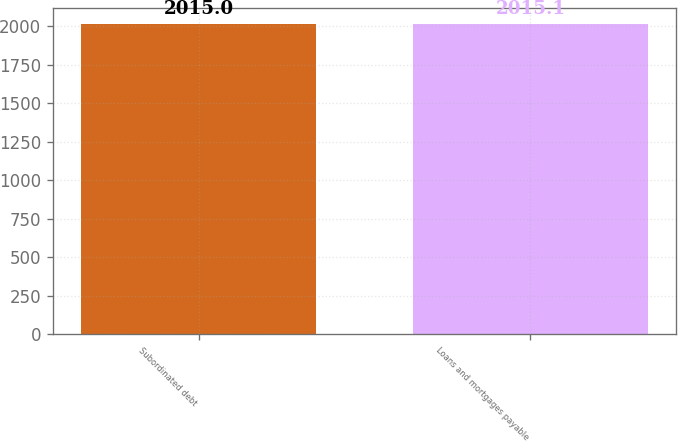<chart> <loc_0><loc_0><loc_500><loc_500><bar_chart><fcel>Subordinated debt<fcel>Loans and mortgages payable<nl><fcel>2015<fcel>2015.1<nl></chart> 